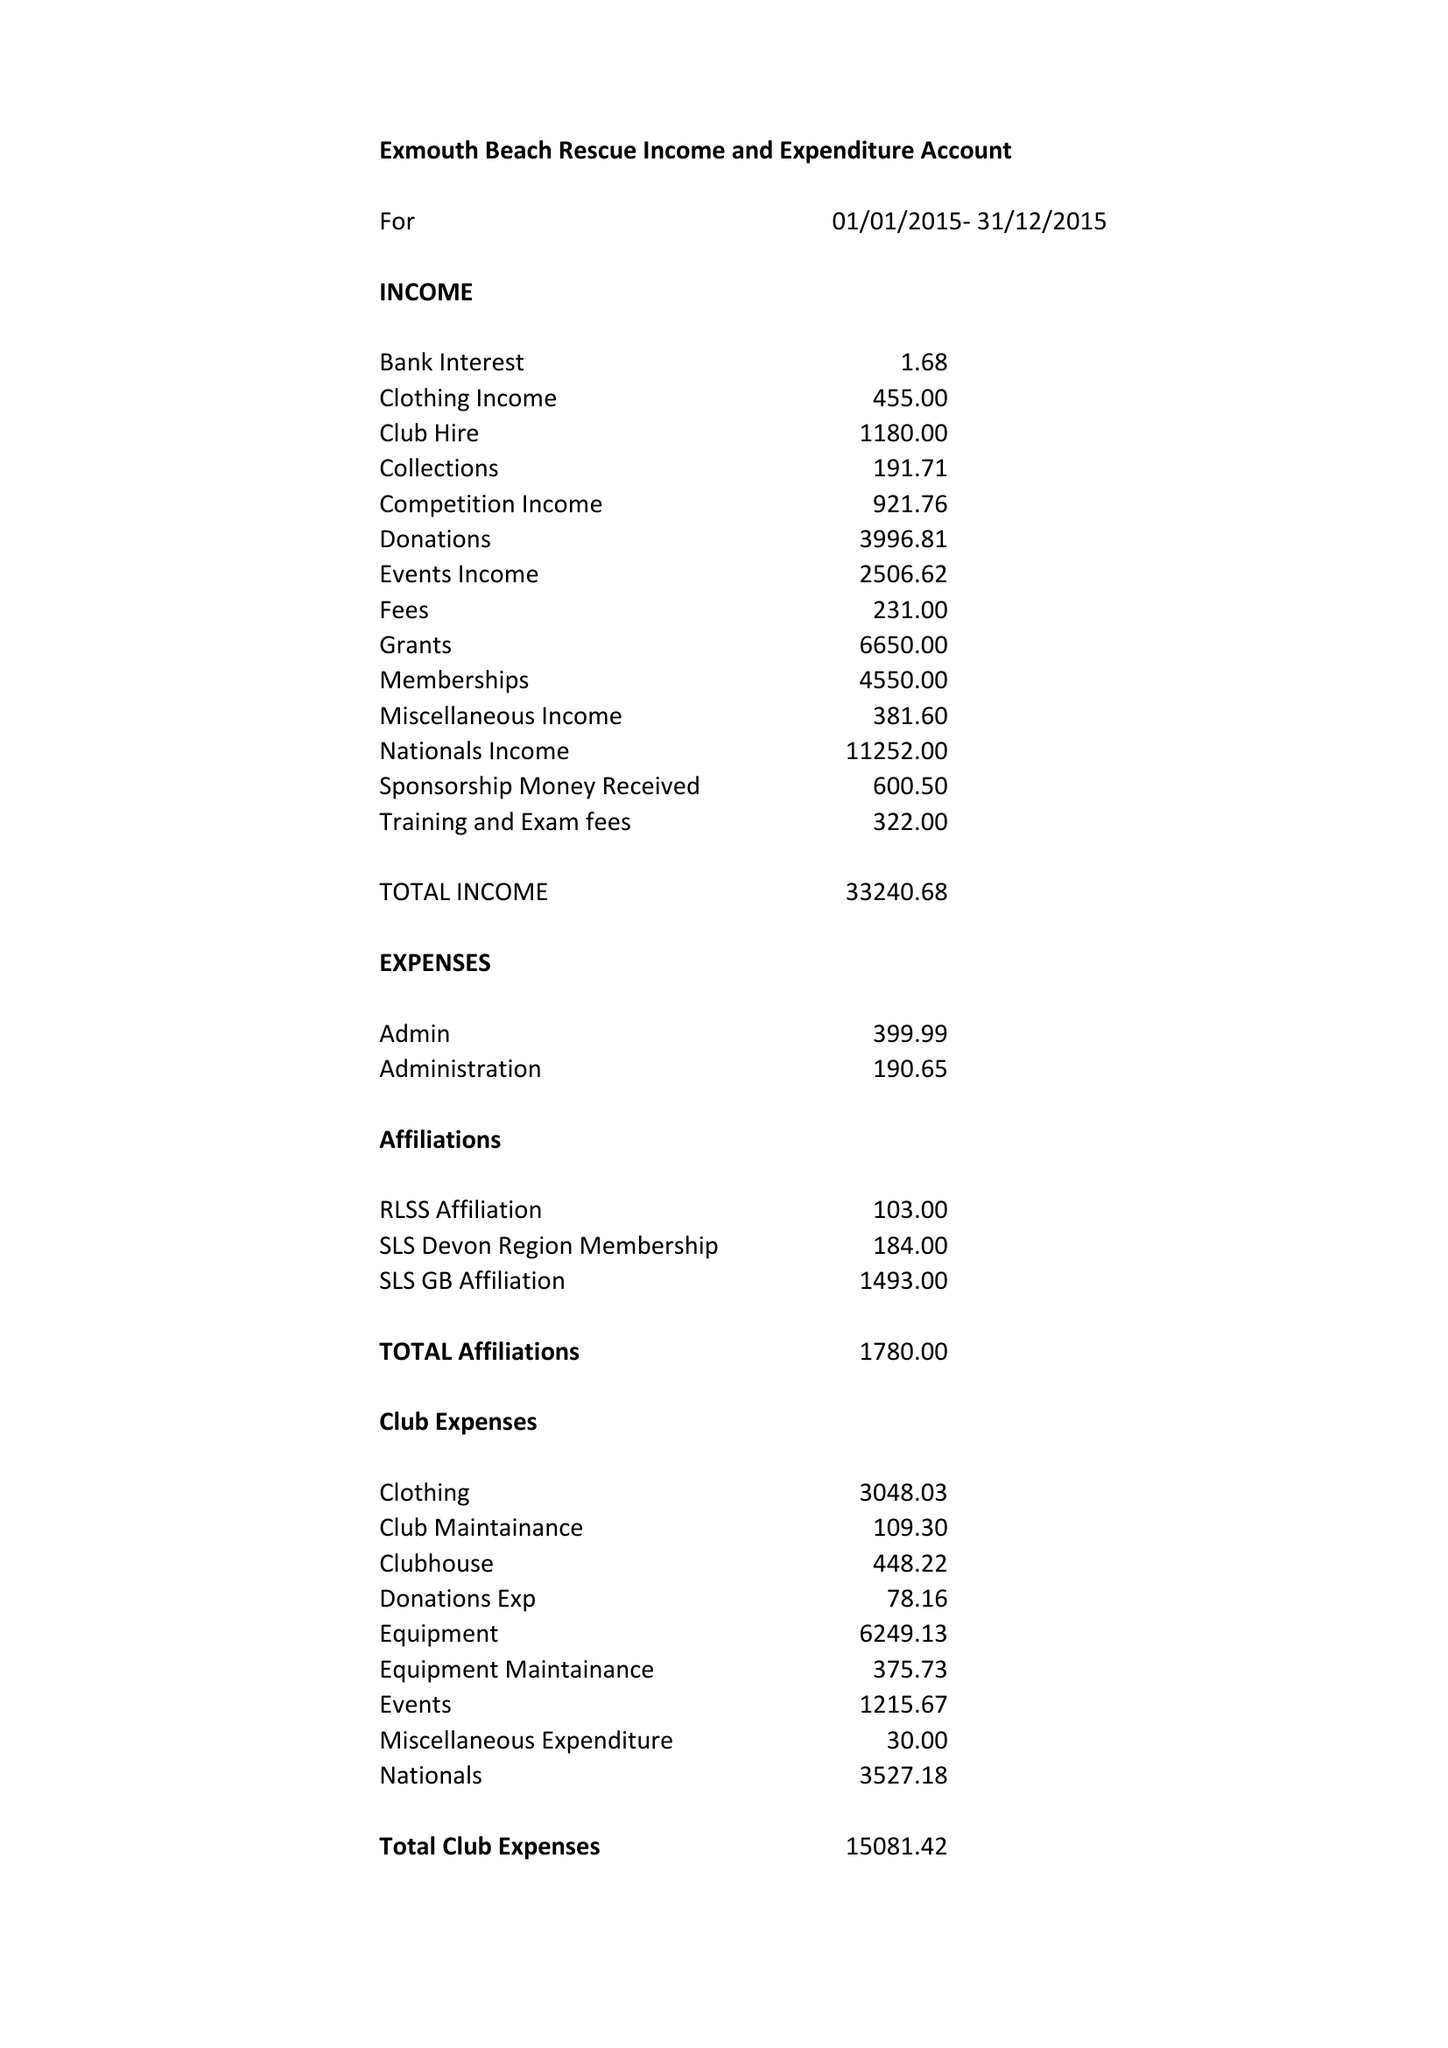What is the value for the charity_name?
Answer the question using a single word or phrase. Exmouth Beach Rescue Club 